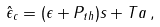Convert formula to latex. <formula><loc_0><loc_0><loc_500><loc_500>\hat { \epsilon } _ { c } = ( \epsilon + P _ { t h } ) s + T a \, ,</formula> 